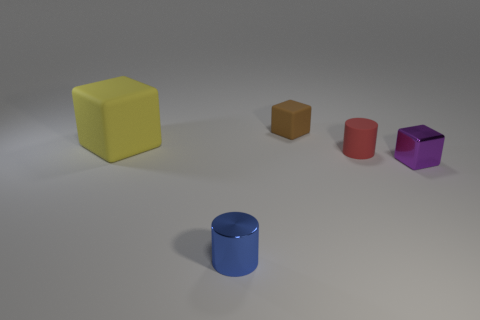Does the small cylinder in front of the purple cube have the same material as the cube that is on the right side of the small brown object?
Make the answer very short. Yes. What is the shape of the shiny thing that is in front of the block right of the tiny cube that is behind the metal cube?
Offer a terse response. Cylinder. What number of other tiny objects have the same material as the yellow object?
Offer a terse response. 2. There is a small block in front of the big rubber cube; what number of tiny things are behind it?
Keep it short and to the point. 2. There is a thing that is to the right of the small brown matte object and left of the small purple block; what shape is it?
Provide a short and direct response. Cylinder. Is there another tiny red matte thing of the same shape as the small red rubber thing?
Provide a succinct answer. No. The purple shiny object that is the same size as the blue metal object is what shape?
Give a very brief answer. Cube. What material is the small purple thing?
Keep it short and to the point. Metal. There is a matte cube that is in front of the matte block to the right of the tiny cylinder that is left of the matte cylinder; what size is it?
Give a very brief answer. Large. What number of rubber objects are big brown cylinders or small objects?
Give a very brief answer. 2. 